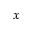Convert formula to latex. <formula><loc_0><loc_0><loc_500><loc_500>x</formula> 